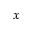Convert formula to latex. <formula><loc_0><loc_0><loc_500><loc_500>x</formula> 